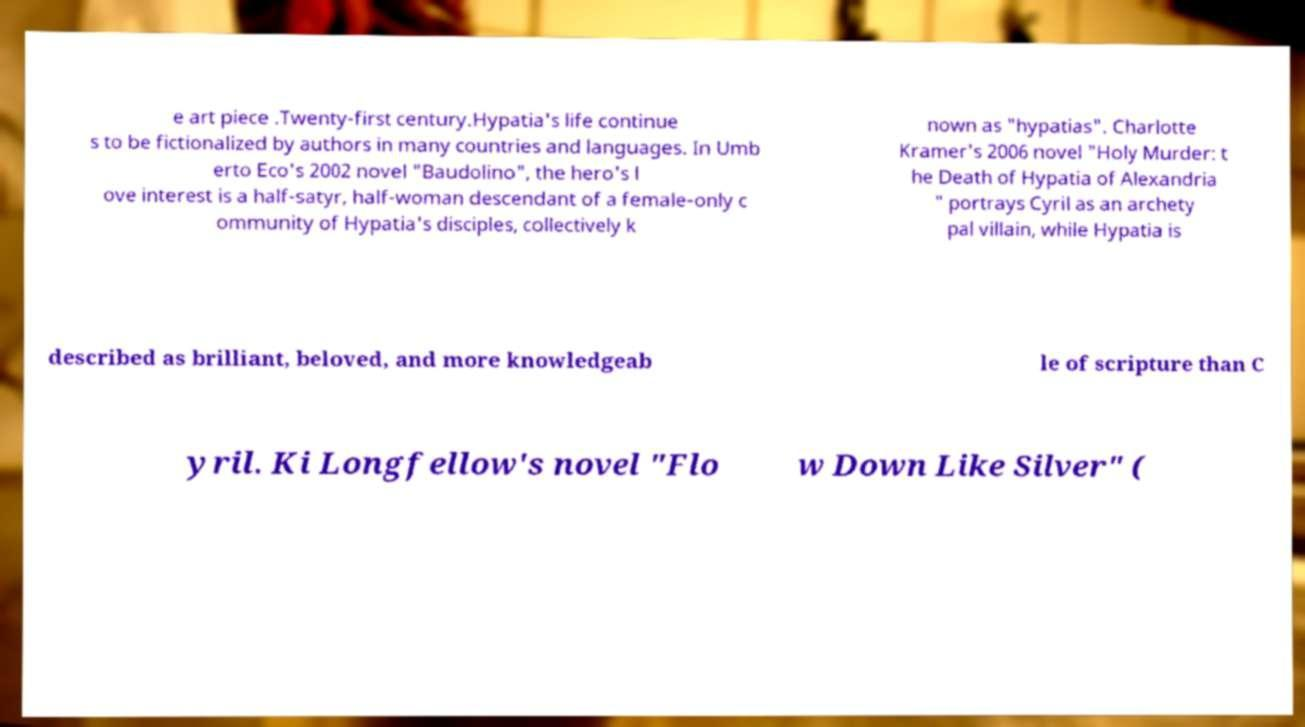Can you accurately transcribe the text from the provided image for me? e art piece .Twenty-first century.Hypatia's life continue s to be fictionalized by authors in many countries and languages. In Umb erto Eco's 2002 novel "Baudolino", the hero's l ove interest is a half-satyr, half-woman descendant of a female-only c ommunity of Hypatia's disciples, collectively k nown as "hypatias". Charlotte Kramer's 2006 novel "Holy Murder: t he Death of Hypatia of Alexandria " portrays Cyril as an archety pal villain, while Hypatia is described as brilliant, beloved, and more knowledgeab le of scripture than C yril. Ki Longfellow's novel "Flo w Down Like Silver" ( 